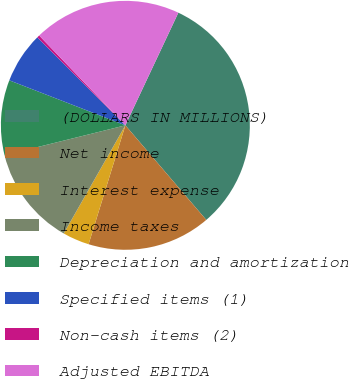Convert chart. <chart><loc_0><loc_0><loc_500><loc_500><pie_chart><fcel>(DOLLARS IN MILLIONS)<fcel>Net income<fcel>Interest expense<fcel>Income taxes<fcel>Depreciation and amortization<fcel>Specified items (1)<fcel>Non-cash items (2)<fcel>Adjusted EBITDA<nl><fcel>31.74%<fcel>16.03%<fcel>3.47%<fcel>12.89%<fcel>9.75%<fcel>6.61%<fcel>0.33%<fcel>19.17%<nl></chart> 